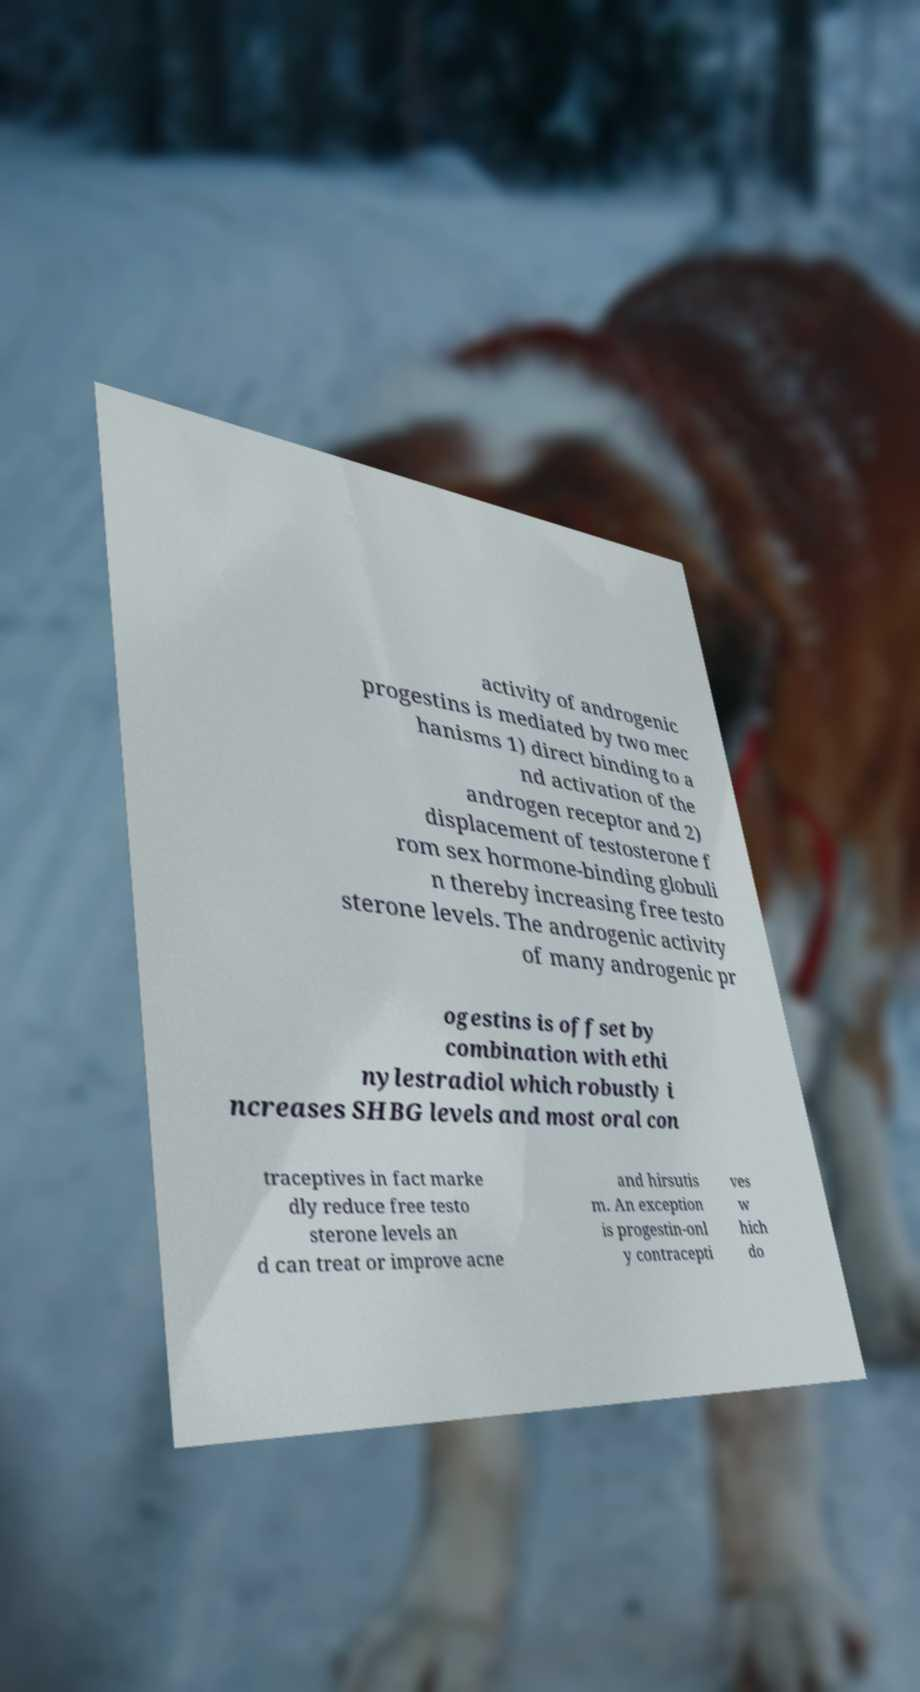There's text embedded in this image that I need extracted. Can you transcribe it verbatim? activity of androgenic progestins is mediated by two mec hanisms 1) direct binding to a nd activation of the androgen receptor and 2) displacement of testosterone f rom sex hormone-binding globuli n thereby increasing free testo sterone levels. The androgenic activity of many androgenic pr ogestins is offset by combination with ethi nylestradiol which robustly i ncreases SHBG levels and most oral con traceptives in fact marke dly reduce free testo sterone levels an d can treat or improve acne and hirsutis m. An exception is progestin-onl y contracepti ves w hich do 